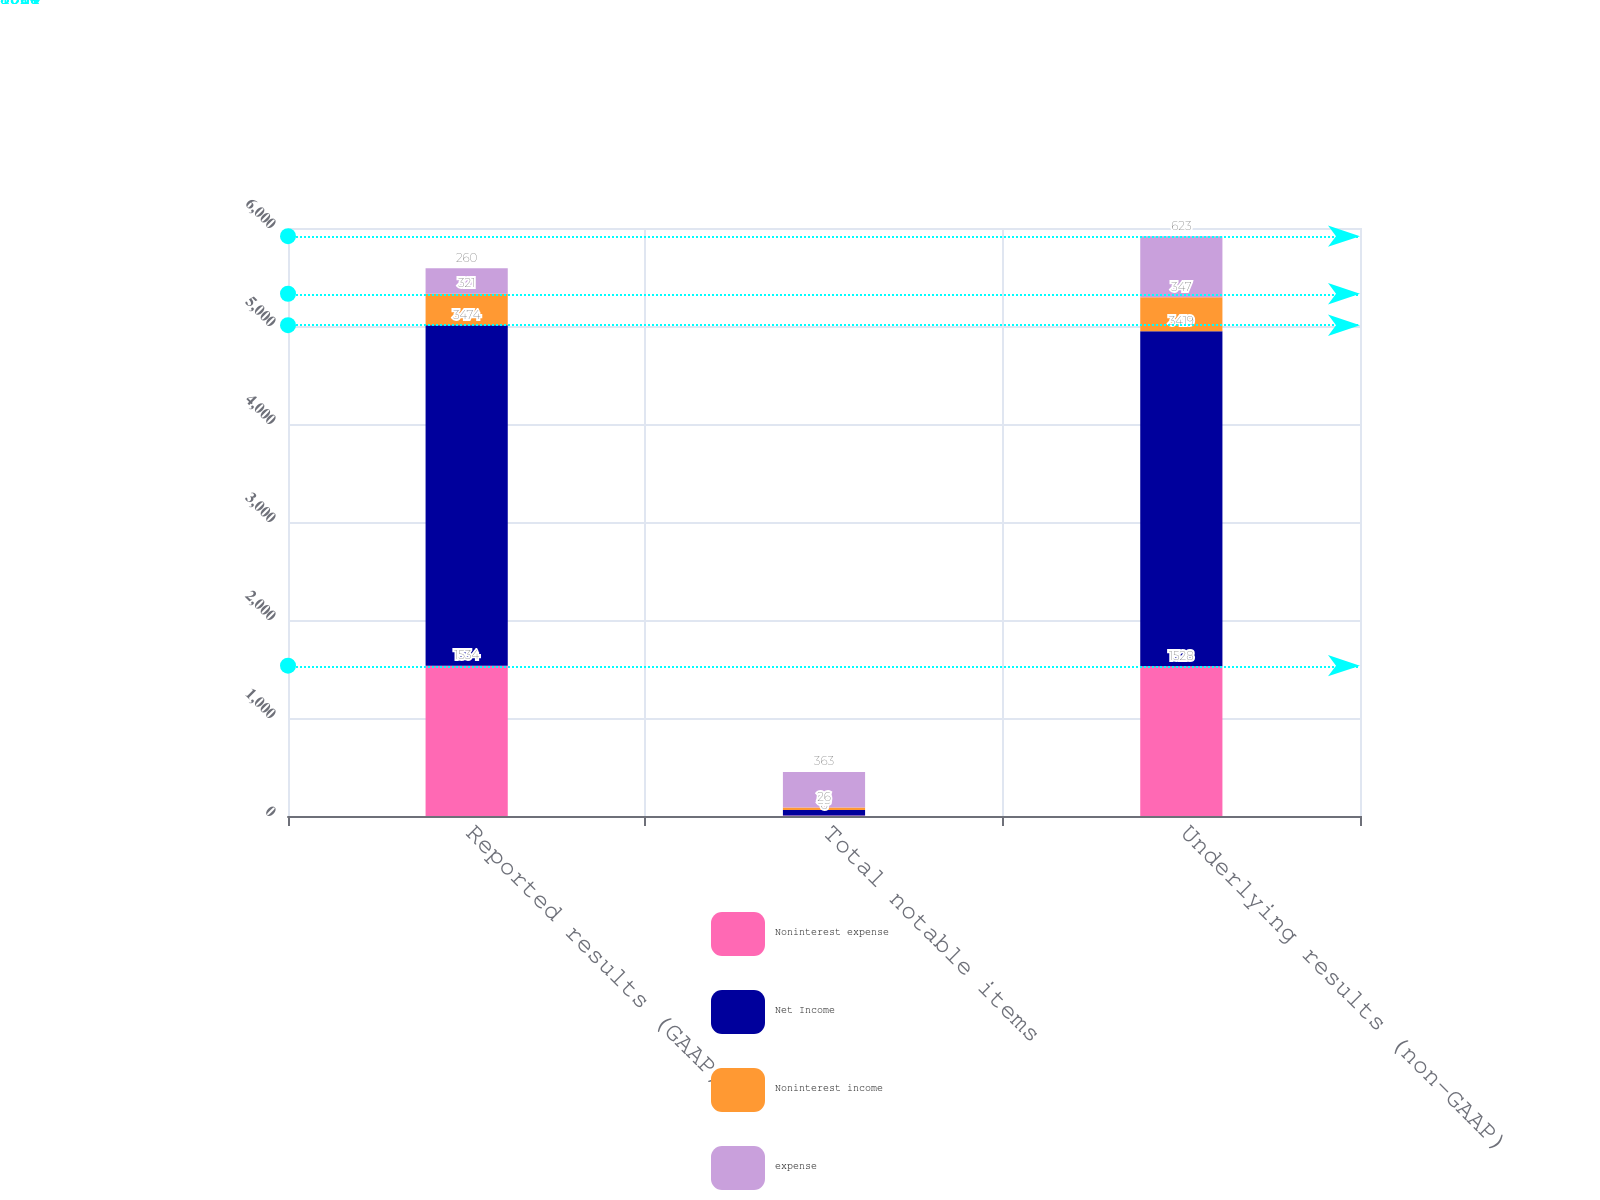<chart> <loc_0><loc_0><loc_500><loc_500><stacked_bar_chart><ecel><fcel>Reported results (GAAP)<fcel>Total notable items<fcel>Underlying results (non-GAAP)<nl><fcel>Noninterest expense<fcel>1534<fcel>6<fcel>1528<nl><fcel>Net Income<fcel>3474<fcel>55<fcel>3419<nl><fcel>Noninterest income<fcel>321<fcel>26<fcel>347<nl><fcel>expense<fcel>260<fcel>363<fcel>623<nl></chart> 